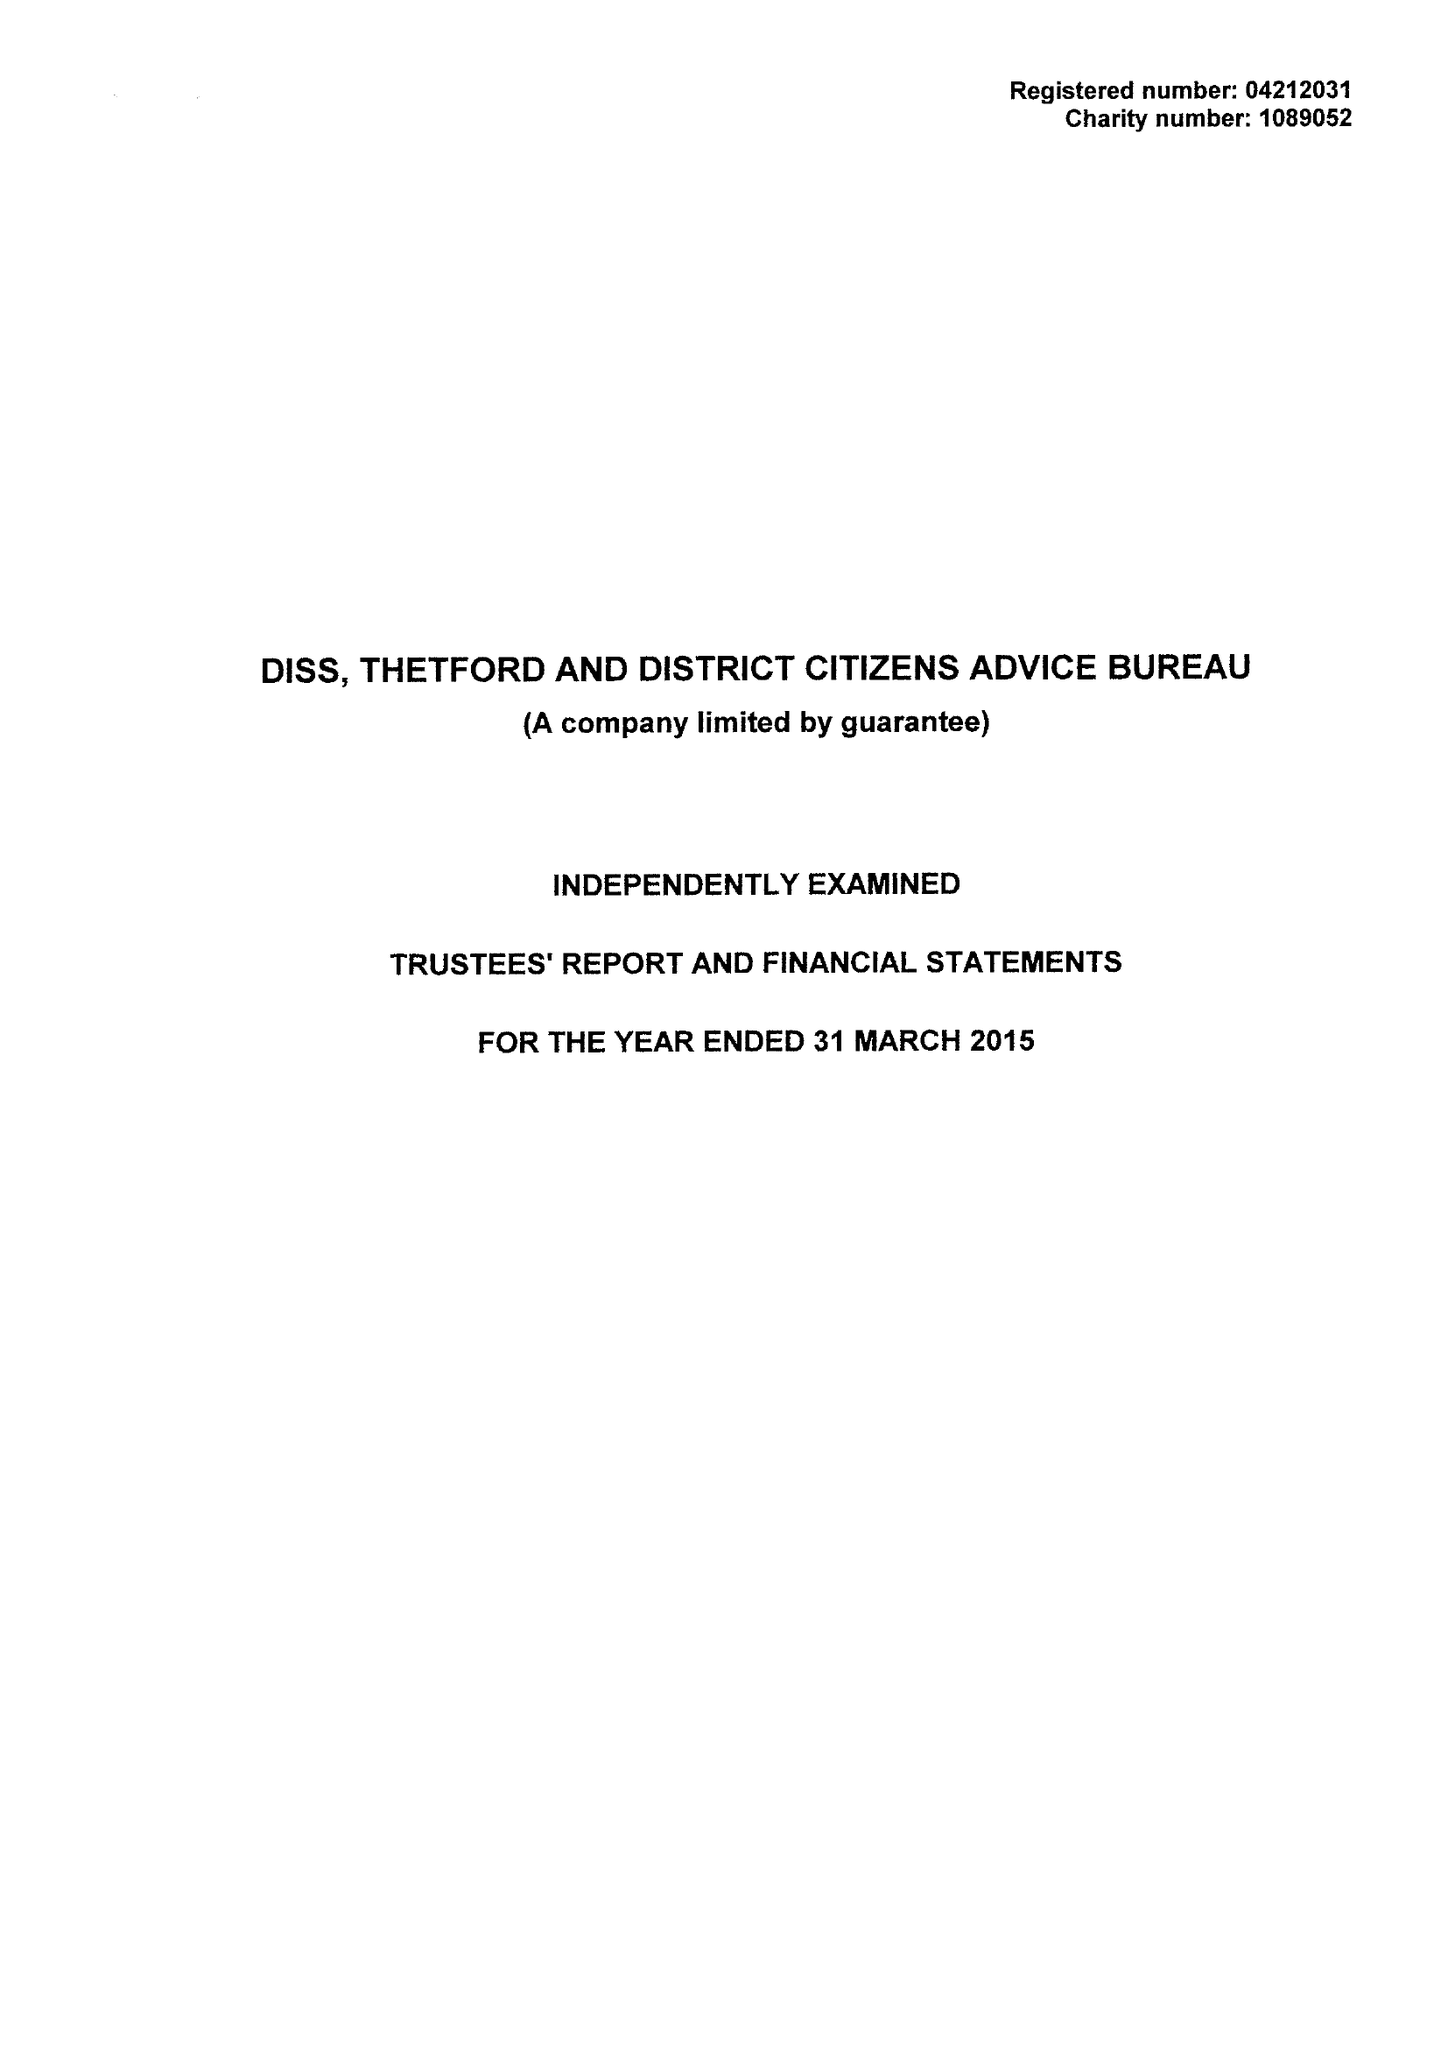What is the value for the address__postcode?
Answer the question using a single word or phrase. IP22 4EH 